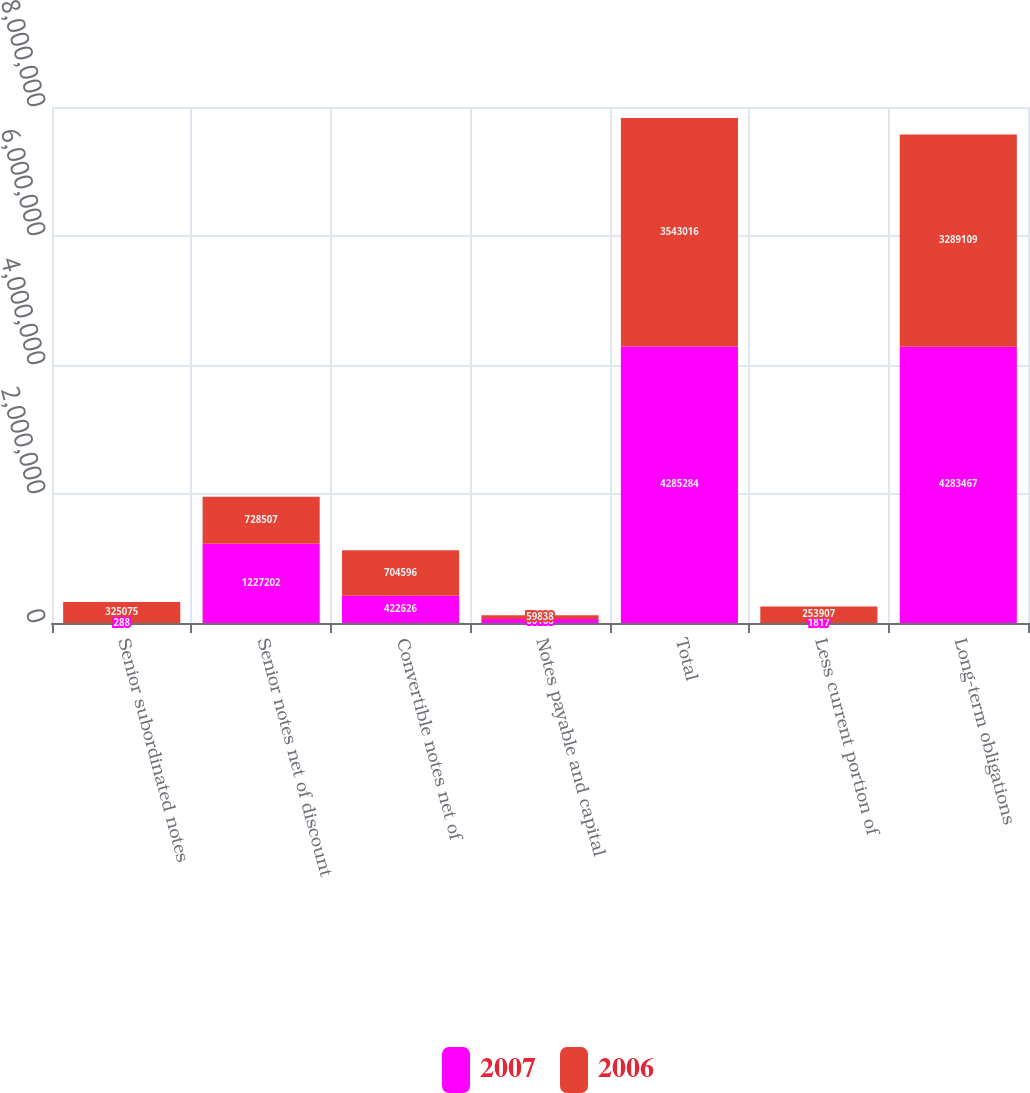Convert chart. <chart><loc_0><loc_0><loc_500><loc_500><stacked_bar_chart><ecel><fcel>Senior subordinated notes<fcel>Senior notes net of discount<fcel>Convertible notes net of<fcel>Notes payable and capital<fcel>Total<fcel>Less current portion of<fcel>Long-term obligations<nl><fcel>2007<fcel>288<fcel>1.2272e+06<fcel>422626<fcel>60168<fcel>4.28528e+06<fcel>1817<fcel>4.28347e+06<nl><fcel>2006<fcel>325075<fcel>728507<fcel>704596<fcel>59838<fcel>3.54302e+06<fcel>253907<fcel>3.28911e+06<nl></chart> 